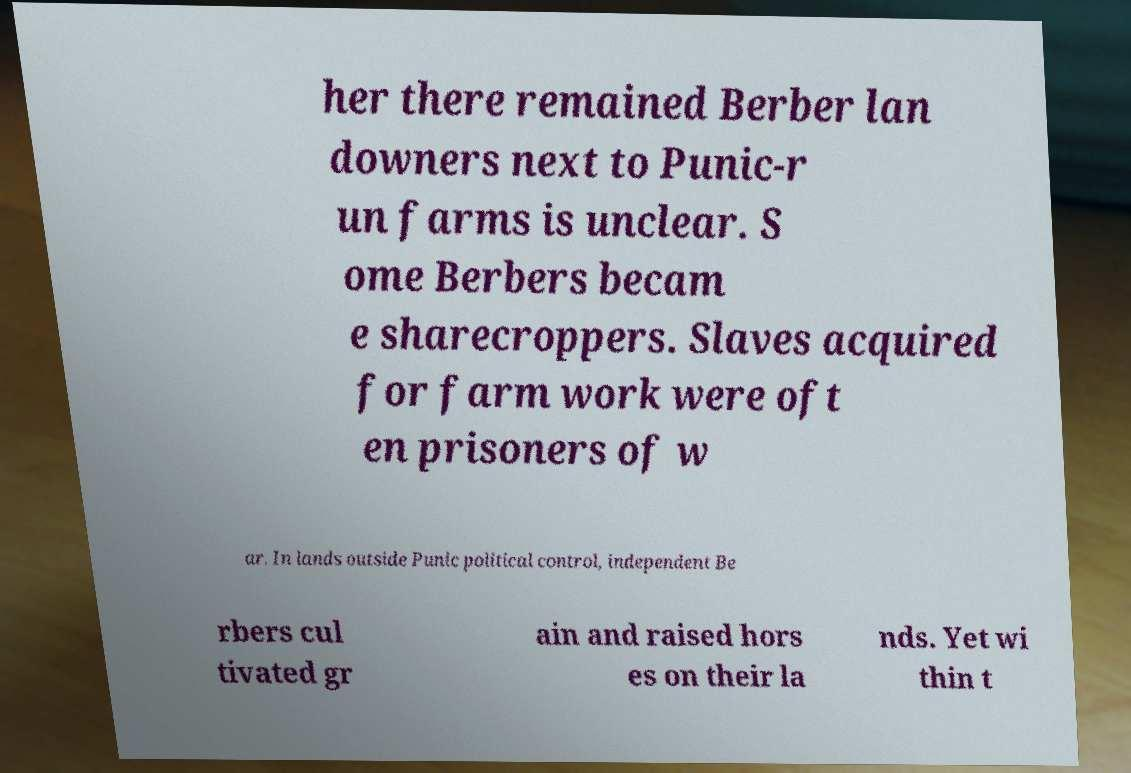There's text embedded in this image that I need extracted. Can you transcribe it verbatim? her there remained Berber lan downers next to Punic-r un farms is unclear. S ome Berbers becam e sharecroppers. Slaves acquired for farm work were oft en prisoners of w ar. In lands outside Punic political control, independent Be rbers cul tivated gr ain and raised hors es on their la nds. Yet wi thin t 